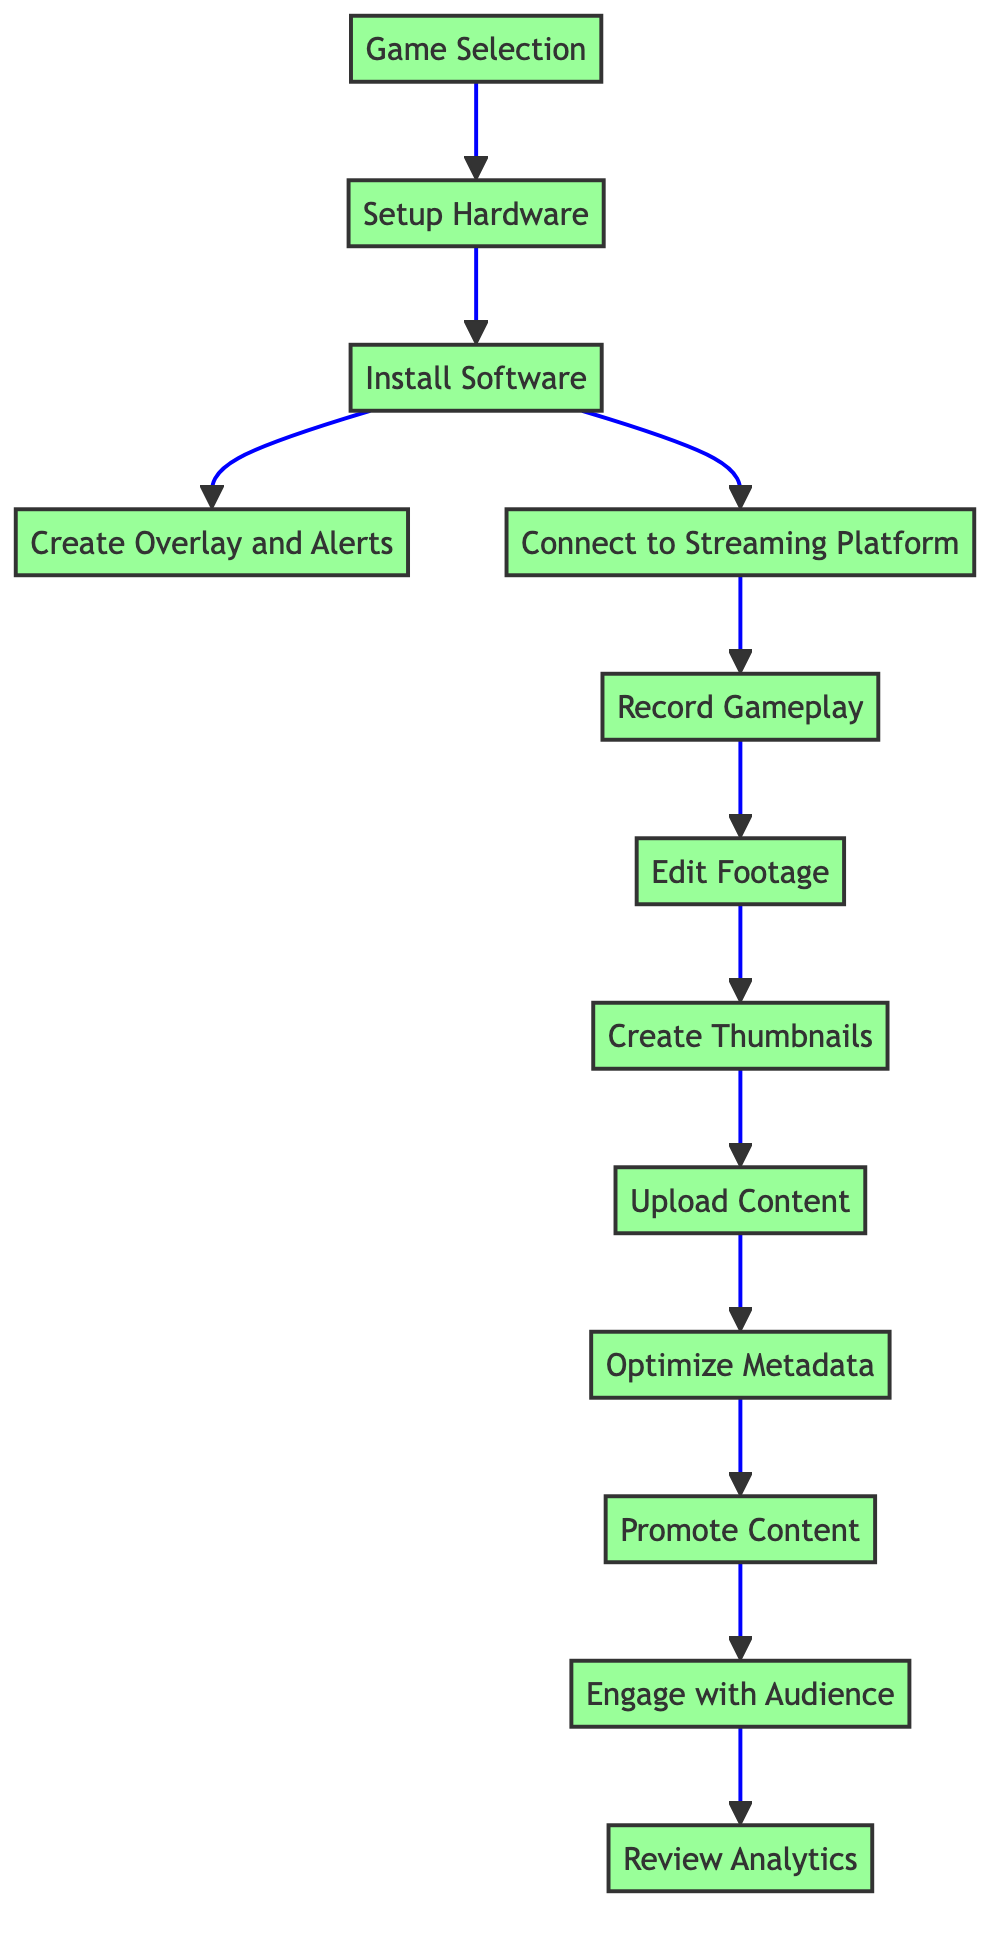What is the first step in the workflow? The first step is the starting point of the flowchart, indicated by the node labeled "Game Selection." This is the initial action that triggers the entire process.
Answer: Game Selection How many total steps are in this workflow? By counting the nodes, we find there are thirteen steps presented in the flowchart, from "Game Selection" to "Review Analytics."
Answer: 13 Which step follows "Connect to Streaming Platform"? The step immediately following "Connect to Streaming Platform" is "Record Gameplay," which shows the next action resulting from establishing the connection to the streaming platform.
Answer: Record Gameplay What is required before "Edit Footage" can be completed? "Edit Footage" cannot be completed until "Record Gameplay" is finished, as it relies on the captured content from the recording step.
Answer: Record Gameplay Which two steps can be completed after "Install Software"? After "Install Software," the next steps that can be completed are "Create Overlay and Alerts" and "Connect to Streaming Platform," indicating parallel processes stemming from the software installation.
Answer: Create Overlay and Alerts, Connect to Streaming Platform What is the final step in the diagram? The last step in the flowchart sequence is labeled "Review Analytics," representing the conclusion of the content creation and upload workflow.
Answer: Review Analytics How many dependencies does "Upload Content" have? "Upload Content" has one dependency, which is "Create Thumbnails." The process of uploading can only proceed once the thumbnails have been designed.
Answer: 1 Which step precedes "Optimize Metadata"? The step that comes before "Optimize Metadata" in the flowchart is "Upload Content," as metadata optimization relies on the content being uploaded.
Answer: Upload Content What is the purpose of "Promote Content"? The "Promote Content" step serves the purpose of sharing the created content across social media and community platforms to increase its visibility and reach a broader audience.
Answer: Share on social media What connections do "Create Overlay and Alerts" and "Connect to Streaming Platform" have with "Install Software"? Both "Create Overlay and Alerts" and "Connect to Streaming Platform" are dependent on "Install Software," meaning that they cannot begin until the software installation step is completed.
Answer: They both depend on Install Software 